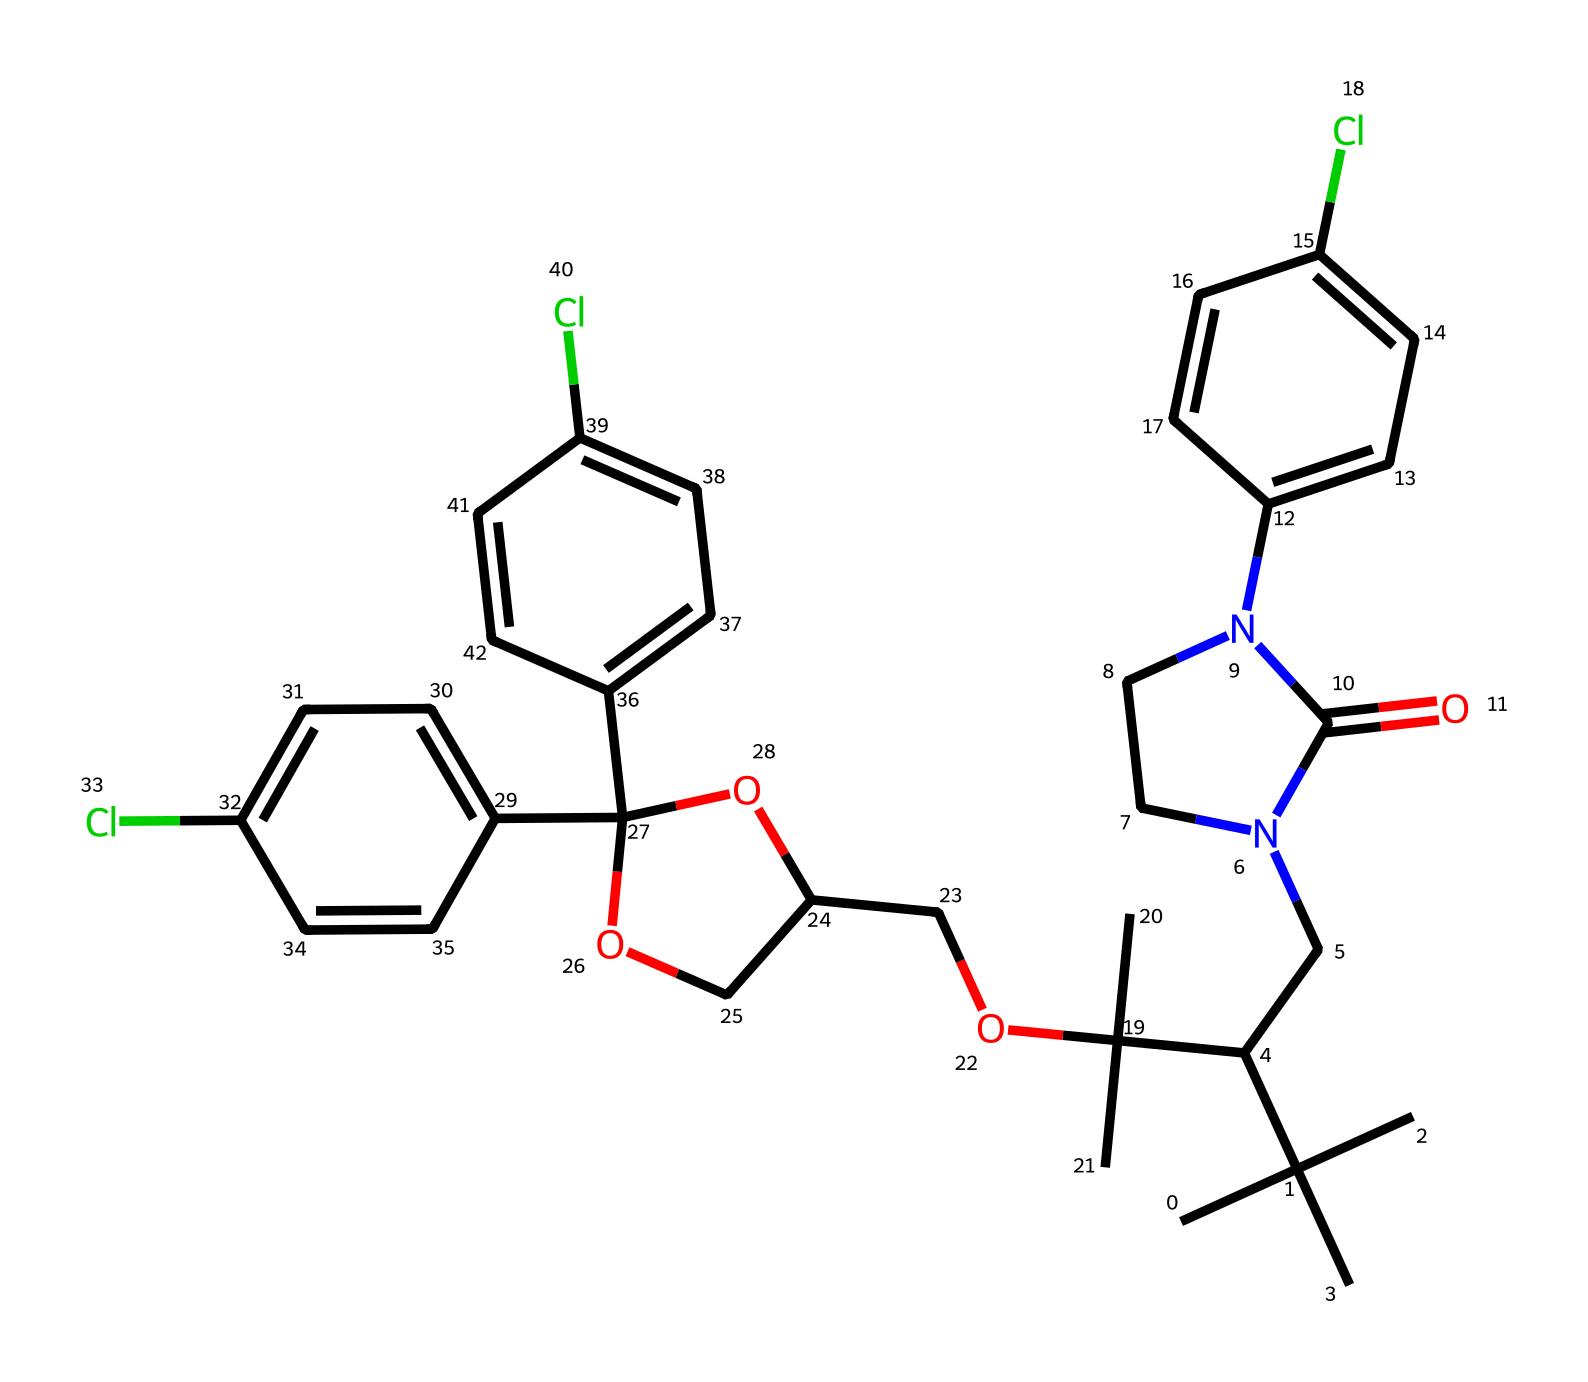What is the molecular formula of propiconazole? To derive the molecular formula from the SMILES representation, you need to identify each unique type of atom present in the chemical structure and count their occurrences. In this case, the atoms present are Carbon (C), Hydrogen (H), Nitrogen (N), Oxygen (O), and Chlorine (Cl). After counting, the full molecular formula is C20H27Cl3N2O2.
Answer: C20H27Cl3N2O2 How many chlorine atoms are present in propiconazole? By analyzing the SMILES code, you can spot the 'Cl' entities, which indicate chlorine atoms. Counting the occurrences reveals there are three instances of 'Cl' in the chemical structure.
Answer: 3 What type of chemical structure does propiconazole belong to? Propiconazole contains various functional groups including nitrogen, which is characteristic of azoles, a class of fungicides. This property categorizes it specifically as a triazole fungicide.
Answer: triazole What is the role of the nitrogen atom in the structure of propiconazole? The nitrogen atoms in propiconazole are part of the triazole ring structure that contributes to its fungicidal activity by inhibiting a specific enzyme within fungi. This functionality is important for its efficacy.
Answer: fungicidal activity How many rings are present in the overall structure of propiconazole? To determine the number of rings, you need to identify cyclic structures within the SMILES representation. The molecule has a total of three aromatic rings based on its description and structure.
Answer: 3 What functional groups are observable in the structure of propiconazole? Observing the structure reveals key functional groups such as -Cl (chlorine), -NH (amine), and - OH (hydroxyl) which contribute to its chemical reactivity and biological function. Each of these groups influences the compound’s behavior as a fungicide.
Answer: -Cl, -NH, -OH What is one of the primary uses of propiconazole? Propiconazole is primarily used as a fungicide in the preservation of wood and materials, preventing fungal growth and degradation in items like furniture. This property makes it essential in wood treatment processes.
Answer: wood preservative 